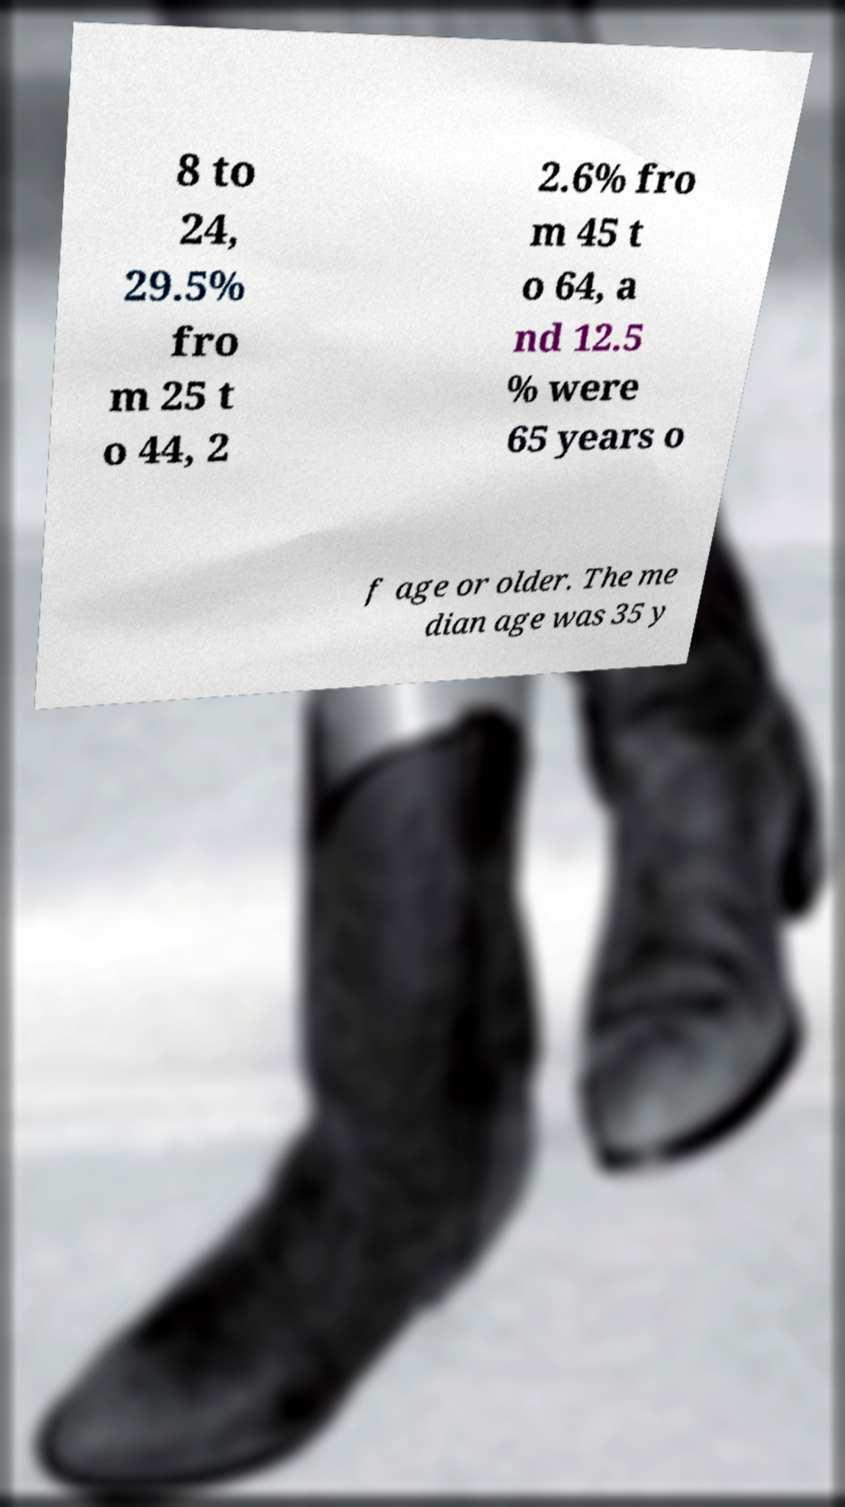There's text embedded in this image that I need extracted. Can you transcribe it verbatim? 8 to 24, 29.5% fro m 25 t o 44, 2 2.6% fro m 45 t o 64, a nd 12.5 % were 65 years o f age or older. The me dian age was 35 y 